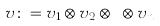<formula> <loc_0><loc_0><loc_500><loc_500>v \colon = v _ { 1 } \otimes v _ { 2 } \otimes \dots \otimes v _ { n }</formula> 